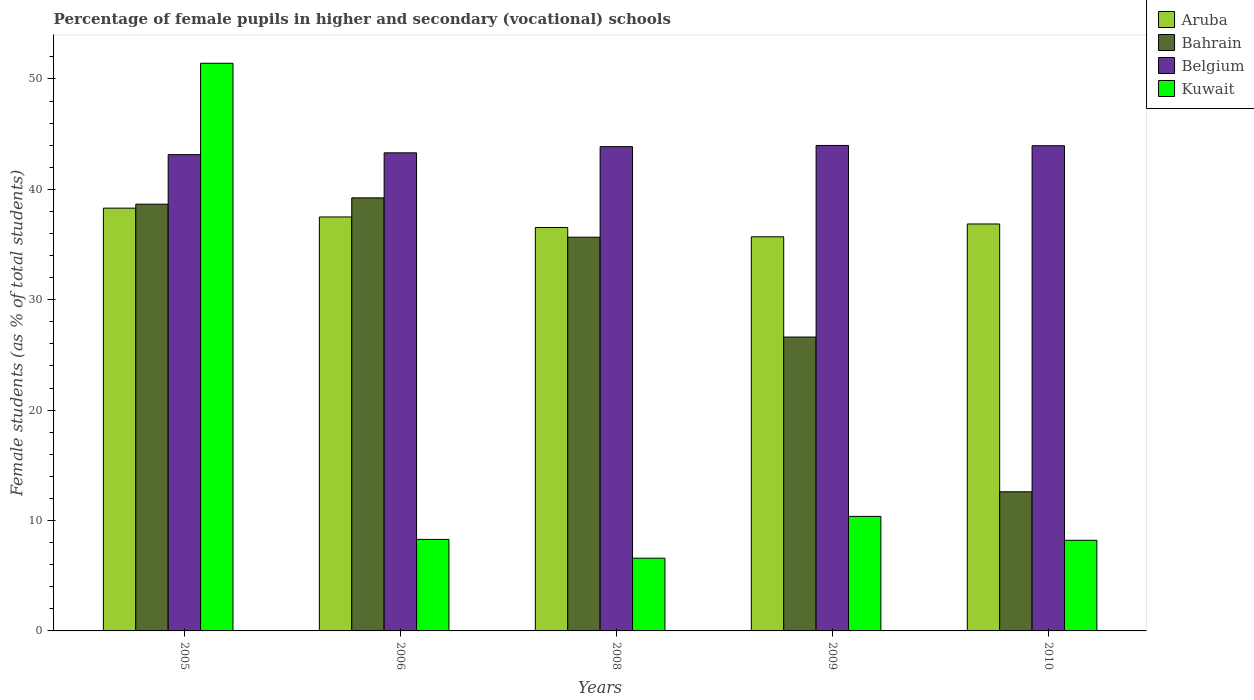How many different coloured bars are there?
Your response must be concise. 4. Are the number of bars per tick equal to the number of legend labels?
Offer a very short reply. Yes. Are the number of bars on each tick of the X-axis equal?
Your answer should be very brief. Yes. How many bars are there on the 5th tick from the left?
Provide a short and direct response. 4. How many bars are there on the 1st tick from the right?
Keep it short and to the point. 4. What is the percentage of female pupils in higher and secondary schools in Bahrain in 2010?
Ensure brevity in your answer.  12.6. Across all years, what is the maximum percentage of female pupils in higher and secondary schools in Kuwait?
Your response must be concise. 51.42. Across all years, what is the minimum percentage of female pupils in higher and secondary schools in Bahrain?
Offer a terse response. 12.6. In which year was the percentage of female pupils in higher and secondary schools in Aruba maximum?
Your answer should be very brief. 2005. In which year was the percentage of female pupils in higher and secondary schools in Aruba minimum?
Make the answer very short. 2009. What is the total percentage of female pupils in higher and secondary schools in Kuwait in the graph?
Offer a terse response. 84.89. What is the difference between the percentage of female pupils in higher and secondary schools in Kuwait in 2006 and that in 2008?
Keep it short and to the point. 1.7. What is the difference between the percentage of female pupils in higher and secondary schools in Belgium in 2010 and the percentage of female pupils in higher and secondary schools in Kuwait in 2006?
Offer a terse response. 35.66. What is the average percentage of female pupils in higher and secondary schools in Belgium per year?
Offer a terse response. 43.65. In the year 2006, what is the difference between the percentage of female pupils in higher and secondary schools in Kuwait and percentage of female pupils in higher and secondary schools in Aruba?
Provide a succinct answer. -29.21. What is the ratio of the percentage of female pupils in higher and secondary schools in Kuwait in 2008 to that in 2010?
Give a very brief answer. 0.8. Is the percentage of female pupils in higher and secondary schools in Kuwait in 2006 less than that in 2010?
Make the answer very short. No. What is the difference between the highest and the second highest percentage of female pupils in higher and secondary schools in Kuwait?
Your answer should be very brief. 41.05. What is the difference between the highest and the lowest percentage of female pupils in higher and secondary schools in Kuwait?
Your answer should be very brief. 44.83. Is the sum of the percentage of female pupils in higher and secondary schools in Belgium in 2005 and 2010 greater than the maximum percentage of female pupils in higher and secondary schools in Bahrain across all years?
Keep it short and to the point. Yes. What does the 2nd bar from the left in 2005 represents?
Provide a succinct answer. Bahrain. What does the 3rd bar from the right in 2006 represents?
Ensure brevity in your answer.  Bahrain. How many bars are there?
Give a very brief answer. 20. Are all the bars in the graph horizontal?
Your answer should be compact. No. What is the difference between two consecutive major ticks on the Y-axis?
Your answer should be compact. 10. Where does the legend appear in the graph?
Offer a very short reply. Top right. How are the legend labels stacked?
Ensure brevity in your answer.  Vertical. What is the title of the graph?
Your response must be concise. Percentage of female pupils in higher and secondary (vocational) schools. What is the label or title of the Y-axis?
Provide a short and direct response. Female students (as % of total students). What is the Female students (as % of total students) in Aruba in 2005?
Ensure brevity in your answer.  38.3. What is the Female students (as % of total students) in Bahrain in 2005?
Your answer should be very brief. 38.66. What is the Female students (as % of total students) of Belgium in 2005?
Your answer should be very brief. 43.14. What is the Female students (as % of total students) of Kuwait in 2005?
Give a very brief answer. 51.42. What is the Female students (as % of total students) of Aruba in 2006?
Make the answer very short. 37.5. What is the Female students (as % of total students) in Bahrain in 2006?
Your response must be concise. 39.23. What is the Female students (as % of total students) of Belgium in 2006?
Your response must be concise. 43.31. What is the Female students (as % of total students) of Kuwait in 2006?
Your answer should be very brief. 8.29. What is the Female students (as % of total students) in Aruba in 2008?
Make the answer very short. 36.55. What is the Female students (as % of total students) of Bahrain in 2008?
Offer a very short reply. 35.67. What is the Female students (as % of total students) of Belgium in 2008?
Offer a very short reply. 43.87. What is the Female students (as % of total students) of Kuwait in 2008?
Offer a very short reply. 6.59. What is the Female students (as % of total students) of Aruba in 2009?
Provide a short and direct response. 35.7. What is the Female students (as % of total students) in Bahrain in 2009?
Give a very brief answer. 26.62. What is the Female students (as % of total students) of Belgium in 2009?
Give a very brief answer. 43.98. What is the Female students (as % of total students) of Kuwait in 2009?
Give a very brief answer. 10.38. What is the Female students (as % of total students) of Aruba in 2010?
Your response must be concise. 36.87. What is the Female students (as % of total students) in Bahrain in 2010?
Provide a succinct answer. 12.6. What is the Female students (as % of total students) of Belgium in 2010?
Ensure brevity in your answer.  43.95. What is the Female students (as % of total students) of Kuwait in 2010?
Your answer should be compact. 8.21. Across all years, what is the maximum Female students (as % of total students) in Aruba?
Offer a very short reply. 38.3. Across all years, what is the maximum Female students (as % of total students) of Bahrain?
Give a very brief answer. 39.23. Across all years, what is the maximum Female students (as % of total students) in Belgium?
Your answer should be very brief. 43.98. Across all years, what is the maximum Female students (as % of total students) of Kuwait?
Your answer should be compact. 51.42. Across all years, what is the minimum Female students (as % of total students) in Aruba?
Ensure brevity in your answer.  35.7. Across all years, what is the minimum Female students (as % of total students) in Bahrain?
Your response must be concise. 12.6. Across all years, what is the minimum Female students (as % of total students) in Belgium?
Offer a very short reply. 43.14. Across all years, what is the minimum Female students (as % of total students) of Kuwait?
Keep it short and to the point. 6.59. What is the total Female students (as % of total students) in Aruba in the graph?
Offer a very short reply. 184.91. What is the total Female students (as % of total students) in Bahrain in the graph?
Offer a terse response. 152.78. What is the total Female students (as % of total students) in Belgium in the graph?
Make the answer very short. 218.25. What is the total Female students (as % of total students) in Kuwait in the graph?
Your response must be concise. 84.89. What is the difference between the Female students (as % of total students) of Aruba in 2005 and that in 2006?
Offer a very short reply. 0.8. What is the difference between the Female students (as % of total students) in Bahrain in 2005 and that in 2006?
Offer a terse response. -0.57. What is the difference between the Female students (as % of total students) in Belgium in 2005 and that in 2006?
Make the answer very short. -0.16. What is the difference between the Female students (as % of total students) in Kuwait in 2005 and that in 2006?
Provide a short and direct response. 43.13. What is the difference between the Female students (as % of total students) in Aruba in 2005 and that in 2008?
Make the answer very short. 1.75. What is the difference between the Female students (as % of total students) of Bahrain in 2005 and that in 2008?
Offer a terse response. 2.99. What is the difference between the Female students (as % of total students) of Belgium in 2005 and that in 2008?
Provide a succinct answer. -0.72. What is the difference between the Female students (as % of total students) in Kuwait in 2005 and that in 2008?
Your answer should be compact. 44.83. What is the difference between the Female students (as % of total students) in Aruba in 2005 and that in 2009?
Your answer should be very brief. 2.6. What is the difference between the Female students (as % of total students) of Bahrain in 2005 and that in 2009?
Your answer should be very brief. 12.04. What is the difference between the Female students (as % of total students) in Belgium in 2005 and that in 2009?
Provide a short and direct response. -0.83. What is the difference between the Female students (as % of total students) in Kuwait in 2005 and that in 2009?
Your answer should be very brief. 41.05. What is the difference between the Female students (as % of total students) in Aruba in 2005 and that in 2010?
Ensure brevity in your answer.  1.43. What is the difference between the Female students (as % of total students) of Bahrain in 2005 and that in 2010?
Keep it short and to the point. 26.05. What is the difference between the Female students (as % of total students) of Belgium in 2005 and that in 2010?
Ensure brevity in your answer.  -0.81. What is the difference between the Female students (as % of total students) in Kuwait in 2005 and that in 2010?
Keep it short and to the point. 43.21. What is the difference between the Female students (as % of total students) of Aruba in 2006 and that in 2008?
Offer a terse response. 0.95. What is the difference between the Female students (as % of total students) in Bahrain in 2006 and that in 2008?
Your answer should be compact. 3.57. What is the difference between the Female students (as % of total students) of Belgium in 2006 and that in 2008?
Ensure brevity in your answer.  -0.56. What is the difference between the Female students (as % of total students) in Kuwait in 2006 and that in 2008?
Offer a very short reply. 1.7. What is the difference between the Female students (as % of total students) in Aruba in 2006 and that in 2009?
Offer a very short reply. 1.8. What is the difference between the Female students (as % of total students) in Bahrain in 2006 and that in 2009?
Make the answer very short. 12.61. What is the difference between the Female students (as % of total students) in Belgium in 2006 and that in 2009?
Make the answer very short. -0.67. What is the difference between the Female students (as % of total students) in Kuwait in 2006 and that in 2009?
Your answer should be very brief. -2.08. What is the difference between the Female students (as % of total students) of Aruba in 2006 and that in 2010?
Offer a terse response. 0.63. What is the difference between the Female students (as % of total students) of Bahrain in 2006 and that in 2010?
Your answer should be compact. 26.63. What is the difference between the Female students (as % of total students) of Belgium in 2006 and that in 2010?
Give a very brief answer. -0.65. What is the difference between the Female students (as % of total students) of Kuwait in 2006 and that in 2010?
Ensure brevity in your answer.  0.08. What is the difference between the Female students (as % of total students) of Aruba in 2008 and that in 2009?
Your answer should be compact. 0.84. What is the difference between the Female students (as % of total students) in Bahrain in 2008 and that in 2009?
Offer a terse response. 9.04. What is the difference between the Female students (as % of total students) of Belgium in 2008 and that in 2009?
Your answer should be compact. -0.11. What is the difference between the Female students (as % of total students) of Kuwait in 2008 and that in 2009?
Make the answer very short. -3.79. What is the difference between the Female students (as % of total students) in Aruba in 2008 and that in 2010?
Offer a terse response. -0.32. What is the difference between the Female students (as % of total students) in Bahrain in 2008 and that in 2010?
Offer a very short reply. 23.06. What is the difference between the Female students (as % of total students) in Belgium in 2008 and that in 2010?
Ensure brevity in your answer.  -0.09. What is the difference between the Female students (as % of total students) of Kuwait in 2008 and that in 2010?
Make the answer very short. -1.62. What is the difference between the Female students (as % of total students) of Aruba in 2009 and that in 2010?
Provide a succinct answer. -1.16. What is the difference between the Female students (as % of total students) of Bahrain in 2009 and that in 2010?
Give a very brief answer. 14.02. What is the difference between the Female students (as % of total students) in Belgium in 2009 and that in 2010?
Your answer should be compact. 0.02. What is the difference between the Female students (as % of total students) of Kuwait in 2009 and that in 2010?
Make the answer very short. 2.16. What is the difference between the Female students (as % of total students) of Aruba in 2005 and the Female students (as % of total students) of Bahrain in 2006?
Offer a very short reply. -0.93. What is the difference between the Female students (as % of total students) of Aruba in 2005 and the Female students (as % of total students) of Belgium in 2006?
Offer a very short reply. -5.01. What is the difference between the Female students (as % of total students) in Aruba in 2005 and the Female students (as % of total students) in Kuwait in 2006?
Your response must be concise. 30.01. What is the difference between the Female students (as % of total students) in Bahrain in 2005 and the Female students (as % of total students) in Belgium in 2006?
Provide a short and direct response. -4.65. What is the difference between the Female students (as % of total students) of Bahrain in 2005 and the Female students (as % of total students) of Kuwait in 2006?
Offer a very short reply. 30.37. What is the difference between the Female students (as % of total students) in Belgium in 2005 and the Female students (as % of total students) in Kuwait in 2006?
Make the answer very short. 34.85. What is the difference between the Female students (as % of total students) in Aruba in 2005 and the Female students (as % of total students) in Bahrain in 2008?
Your answer should be very brief. 2.63. What is the difference between the Female students (as % of total students) of Aruba in 2005 and the Female students (as % of total students) of Belgium in 2008?
Your response must be concise. -5.57. What is the difference between the Female students (as % of total students) in Aruba in 2005 and the Female students (as % of total students) in Kuwait in 2008?
Your response must be concise. 31.71. What is the difference between the Female students (as % of total students) of Bahrain in 2005 and the Female students (as % of total students) of Belgium in 2008?
Give a very brief answer. -5.21. What is the difference between the Female students (as % of total students) of Bahrain in 2005 and the Female students (as % of total students) of Kuwait in 2008?
Make the answer very short. 32.07. What is the difference between the Female students (as % of total students) of Belgium in 2005 and the Female students (as % of total students) of Kuwait in 2008?
Make the answer very short. 36.56. What is the difference between the Female students (as % of total students) of Aruba in 2005 and the Female students (as % of total students) of Bahrain in 2009?
Ensure brevity in your answer.  11.68. What is the difference between the Female students (as % of total students) in Aruba in 2005 and the Female students (as % of total students) in Belgium in 2009?
Give a very brief answer. -5.68. What is the difference between the Female students (as % of total students) of Aruba in 2005 and the Female students (as % of total students) of Kuwait in 2009?
Offer a very short reply. 27.92. What is the difference between the Female students (as % of total students) of Bahrain in 2005 and the Female students (as % of total students) of Belgium in 2009?
Ensure brevity in your answer.  -5.32. What is the difference between the Female students (as % of total students) in Bahrain in 2005 and the Female students (as % of total students) in Kuwait in 2009?
Your answer should be compact. 28.28. What is the difference between the Female students (as % of total students) in Belgium in 2005 and the Female students (as % of total students) in Kuwait in 2009?
Give a very brief answer. 32.77. What is the difference between the Female students (as % of total students) of Aruba in 2005 and the Female students (as % of total students) of Bahrain in 2010?
Keep it short and to the point. 25.69. What is the difference between the Female students (as % of total students) in Aruba in 2005 and the Female students (as % of total students) in Belgium in 2010?
Provide a succinct answer. -5.66. What is the difference between the Female students (as % of total students) of Aruba in 2005 and the Female students (as % of total students) of Kuwait in 2010?
Offer a terse response. 30.09. What is the difference between the Female students (as % of total students) of Bahrain in 2005 and the Female students (as % of total students) of Belgium in 2010?
Offer a terse response. -5.3. What is the difference between the Female students (as % of total students) in Bahrain in 2005 and the Female students (as % of total students) in Kuwait in 2010?
Give a very brief answer. 30.45. What is the difference between the Female students (as % of total students) in Belgium in 2005 and the Female students (as % of total students) in Kuwait in 2010?
Provide a succinct answer. 34.93. What is the difference between the Female students (as % of total students) of Aruba in 2006 and the Female students (as % of total students) of Bahrain in 2008?
Your answer should be very brief. 1.83. What is the difference between the Female students (as % of total students) in Aruba in 2006 and the Female students (as % of total students) in Belgium in 2008?
Give a very brief answer. -6.37. What is the difference between the Female students (as % of total students) of Aruba in 2006 and the Female students (as % of total students) of Kuwait in 2008?
Provide a succinct answer. 30.91. What is the difference between the Female students (as % of total students) of Bahrain in 2006 and the Female students (as % of total students) of Belgium in 2008?
Ensure brevity in your answer.  -4.64. What is the difference between the Female students (as % of total students) in Bahrain in 2006 and the Female students (as % of total students) in Kuwait in 2008?
Offer a terse response. 32.64. What is the difference between the Female students (as % of total students) in Belgium in 2006 and the Female students (as % of total students) in Kuwait in 2008?
Provide a succinct answer. 36.72. What is the difference between the Female students (as % of total students) of Aruba in 2006 and the Female students (as % of total students) of Bahrain in 2009?
Offer a very short reply. 10.88. What is the difference between the Female students (as % of total students) in Aruba in 2006 and the Female students (as % of total students) in Belgium in 2009?
Provide a short and direct response. -6.48. What is the difference between the Female students (as % of total students) of Aruba in 2006 and the Female students (as % of total students) of Kuwait in 2009?
Provide a short and direct response. 27.12. What is the difference between the Female students (as % of total students) of Bahrain in 2006 and the Female students (as % of total students) of Belgium in 2009?
Your answer should be very brief. -4.75. What is the difference between the Female students (as % of total students) of Bahrain in 2006 and the Female students (as % of total students) of Kuwait in 2009?
Provide a succinct answer. 28.85. What is the difference between the Female students (as % of total students) of Belgium in 2006 and the Female students (as % of total students) of Kuwait in 2009?
Your answer should be very brief. 32.93. What is the difference between the Female students (as % of total students) of Aruba in 2006 and the Female students (as % of total students) of Bahrain in 2010?
Ensure brevity in your answer.  24.9. What is the difference between the Female students (as % of total students) of Aruba in 2006 and the Female students (as % of total students) of Belgium in 2010?
Ensure brevity in your answer.  -6.45. What is the difference between the Female students (as % of total students) of Aruba in 2006 and the Female students (as % of total students) of Kuwait in 2010?
Keep it short and to the point. 29.29. What is the difference between the Female students (as % of total students) in Bahrain in 2006 and the Female students (as % of total students) in Belgium in 2010?
Provide a short and direct response. -4.72. What is the difference between the Female students (as % of total students) in Bahrain in 2006 and the Female students (as % of total students) in Kuwait in 2010?
Your answer should be very brief. 31.02. What is the difference between the Female students (as % of total students) in Belgium in 2006 and the Female students (as % of total students) in Kuwait in 2010?
Give a very brief answer. 35.1. What is the difference between the Female students (as % of total students) in Aruba in 2008 and the Female students (as % of total students) in Bahrain in 2009?
Your answer should be compact. 9.92. What is the difference between the Female students (as % of total students) in Aruba in 2008 and the Female students (as % of total students) in Belgium in 2009?
Provide a succinct answer. -7.43. What is the difference between the Female students (as % of total students) in Aruba in 2008 and the Female students (as % of total students) in Kuwait in 2009?
Provide a succinct answer. 26.17. What is the difference between the Female students (as % of total students) in Bahrain in 2008 and the Female students (as % of total students) in Belgium in 2009?
Make the answer very short. -8.31. What is the difference between the Female students (as % of total students) of Bahrain in 2008 and the Female students (as % of total students) of Kuwait in 2009?
Offer a very short reply. 25.29. What is the difference between the Female students (as % of total students) of Belgium in 2008 and the Female students (as % of total students) of Kuwait in 2009?
Your answer should be compact. 33.49. What is the difference between the Female students (as % of total students) of Aruba in 2008 and the Female students (as % of total students) of Bahrain in 2010?
Make the answer very short. 23.94. What is the difference between the Female students (as % of total students) of Aruba in 2008 and the Female students (as % of total students) of Belgium in 2010?
Give a very brief answer. -7.41. What is the difference between the Female students (as % of total students) of Aruba in 2008 and the Female students (as % of total students) of Kuwait in 2010?
Ensure brevity in your answer.  28.33. What is the difference between the Female students (as % of total students) in Bahrain in 2008 and the Female students (as % of total students) in Belgium in 2010?
Your response must be concise. -8.29. What is the difference between the Female students (as % of total students) of Bahrain in 2008 and the Female students (as % of total students) of Kuwait in 2010?
Your response must be concise. 27.45. What is the difference between the Female students (as % of total students) of Belgium in 2008 and the Female students (as % of total students) of Kuwait in 2010?
Offer a terse response. 35.66. What is the difference between the Female students (as % of total students) of Aruba in 2009 and the Female students (as % of total students) of Bahrain in 2010?
Your answer should be compact. 23.1. What is the difference between the Female students (as % of total students) in Aruba in 2009 and the Female students (as % of total students) in Belgium in 2010?
Your response must be concise. -8.25. What is the difference between the Female students (as % of total students) of Aruba in 2009 and the Female students (as % of total students) of Kuwait in 2010?
Your answer should be very brief. 27.49. What is the difference between the Female students (as % of total students) of Bahrain in 2009 and the Female students (as % of total students) of Belgium in 2010?
Your answer should be very brief. -17.33. What is the difference between the Female students (as % of total students) of Bahrain in 2009 and the Female students (as % of total students) of Kuwait in 2010?
Ensure brevity in your answer.  18.41. What is the difference between the Female students (as % of total students) of Belgium in 2009 and the Female students (as % of total students) of Kuwait in 2010?
Your answer should be compact. 35.77. What is the average Female students (as % of total students) in Aruba per year?
Make the answer very short. 36.98. What is the average Female students (as % of total students) in Bahrain per year?
Give a very brief answer. 30.56. What is the average Female students (as % of total students) in Belgium per year?
Offer a terse response. 43.65. What is the average Female students (as % of total students) in Kuwait per year?
Your answer should be compact. 16.98. In the year 2005, what is the difference between the Female students (as % of total students) of Aruba and Female students (as % of total students) of Bahrain?
Your answer should be compact. -0.36. In the year 2005, what is the difference between the Female students (as % of total students) in Aruba and Female students (as % of total students) in Belgium?
Make the answer very short. -4.85. In the year 2005, what is the difference between the Female students (as % of total students) of Aruba and Female students (as % of total students) of Kuwait?
Provide a succinct answer. -13.13. In the year 2005, what is the difference between the Female students (as % of total students) in Bahrain and Female students (as % of total students) in Belgium?
Provide a succinct answer. -4.49. In the year 2005, what is the difference between the Female students (as % of total students) of Bahrain and Female students (as % of total students) of Kuwait?
Provide a short and direct response. -12.77. In the year 2005, what is the difference between the Female students (as % of total students) in Belgium and Female students (as % of total students) in Kuwait?
Your answer should be very brief. -8.28. In the year 2006, what is the difference between the Female students (as % of total students) in Aruba and Female students (as % of total students) in Bahrain?
Your answer should be compact. -1.73. In the year 2006, what is the difference between the Female students (as % of total students) of Aruba and Female students (as % of total students) of Belgium?
Provide a succinct answer. -5.81. In the year 2006, what is the difference between the Female students (as % of total students) of Aruba and Female students (as % of total students) of Kuwait?
Ensure brevity in your answer.  29.21. In the year 2006, what is the difference between the Female students (as % of total students) of Bahrain and Female students (as % of total students) of Belgium?
Offer a terse response. -4.08. In the year 2006, what is the difference between the Female students (as % of total students) of Bahrain and Female students (as % of total students) of Kuwait?
Offer a terse response. 30.94. In the year 2006, what is the difference between the Female students (as % of total students) of Belgium and Female students (as % of total students) of Kuwait?
Offer a terse response. 35.02. In the year 2008, what is the difference between the Female students (as % of total students) in Aruba and Female students (as % of total students) in Bahrain?
Your answer should be compact. 0.88. In the year 2008, what is the difference between the Female students (as % of total students) in Aruba and Female students (as % of total students) in Belgium?
Offer a very short reply. -7.32. In the year 2008, what is the difference between the Female students (as % of total students) of Aruba and Female students (as % of total students) of Kuwait?
Ensure brevity in your answer.  29.96. In the year 2008, what is the difference between the Female students (as % of total students) in Bahrain and Female students (as % of total students) in Belgium?
Provide a succinct answer. -8.2. In the year 2008, what is the difference between the Female students (as % of total students) of Bahrain and Female students (as % of total students) of Kuwait?
Make the answer very short. 29.08. In the year 2008, what is the difference between the Female students (as % of total students) in Belgium and Female students (as % of total students) in Kuwait?
Your response must be concise. 37.28. In the year 2009, what is the difference between the Female students (as % of total students) in Aruba and Female students (as % of total students) in Bahrain?
Your response must be concise. 9.08. In the year 2009, what is the difference between the Female students (as % of total students) in Aruba and Female students (as % of total students) in Belgium?
Offer a very short reply. -8.27. In the year 2009, what is the difference between the Female students (as % of total students) of Aruba and Female students (as % of total students) of Kuwait?
Your answer should be very brief. 25.33. In the year 2009, what is the difference between the Female students (as % of total students) in Bahrain and Female students (as % of total students) in Belgium?
Give a very brief answer. -17.36. In the year 2009, what is the difference between the Female students (as % of total students) in Bahrain and Female students (as % of total students) in Kuwait?
Offer a very short reply. 16.25. In the year 2009, what is the difference between the Female students (as % of total students) of Belgium and Female students (as % of total students) of Kuwait?
Your response must be concise. 33.6. In the year 2010, what is the difference between the Female students (as % of total students) of Aruba and Female students (as % of total students) of Bahrain?
Keep it short and to the point. 24.26. In the year 2010, what is the difference between the Female students (as % of total students) of Aruba and Female students (as % of total students) of Belgium?
Provide a succinct answer. -7.09. In the year 2010, what is the difference between the Female students (as % of total students) of Aruba and Female students (as % of total students) of Kuwait?
Provide a succinct answer. 28.65. In the year 2010, what is the difference between the Female students (as % of total students) of Bahrain and Female students (as % of total students) of Belgium?
Provide a short and direct response. -31.35. In the year 2010, what is the difference between the Female students (as % of total students) in Bahrain and Female students (as % of total students) in Kuwait?
Your answer should be very brief. 4.39. In the year 2010, what is the difference between the Female students (as % of total students) of Belgium and Female students (as % of total students) of Kuwait?
Your response must be concise. 35.74. What is the ratio of the Female students (as % of total students) of Aruba in 2005 to that in 2006?
Give a very brief answer. 1.02. What is the ratio of the Female students (as % of total students) in Bahrain in 2005 to that in 2006?
Your answer should be very brief. 0.99. What is the ratio of the Female students (as % of total students) in Kuwait in 2005 to that in 2006?
Keep it short and to the point. 6.2. What is the ratio of the Female students (as % of total students) in Aruba in 2005 to that in 2008?
Provide a short and direct response. 1.05. What is the ratio of the Female students (as % of total students) of Bahrain in 2005 to that in 2008?
Your answer should be very brief. 1.08. What is the ratio of the Female students (as % of total students) in Belgium in 2005 to that in 2008?
Keep it short and to the point. 0.98. What is the ratio of the Female students (as % of total students) in Kuwait in 2005 to that in 2008?
Make the answer very short. 7.8. What is the ratio of the Female students (as % of total students) in Aruba in 2005 to that in 2009?
Provide a short and direct response. 1.07. What is the ratio of the Female students (as % of total students) in Bahrain in 2005 to that in 2009?
Ensure brevity in your answer.  1.45. What is the ratio of the Female students (as % of total students) of Belgium in 2005 to that in 2009?
Make the answer very short. 0.98. What is the ratio of the Female students (as % of total students) of Kuwait in 2005 to that in 2009?
Your answer should be compact. 4.96. What is the ratio of the Female students (as % of total students) of Aruba in 2005 to that in 2010?
Give a very brief answer. 1.04. What is the ratio of the Female students (as % of total students) in Bahrain in 2005 to that in 2010?
Provide a succinct answer. 3.07. What is the ratio of the Female students (as % of total students) of Belgium in 2005 to that in 2010?
Keep it short and to the point. 0.98. What is the ratio of the Female students (as % of total students) of Kuwait in 2005 to that in 2010?
Ensure brevity in your answer.  6.26. What is the ratio of the Female students (as % of total students) in Aruba in 2006 to that in 2008?
Offer a very short reply. 1.03. What is the ratio of the Female students (as % of total students) in Belgium in 2006 to that in 2008?
Provide a succinct answer. 0.99. What is the ratio of the Female students (as % of total students) of Kuwait in 2006 to that in 2008?
Ensure brevity in your answer.  1.26. What is the ratio of the Female students (as % of total students) of Aruba in 2006 to that in 2009?
Your answer should be very brief. 1.05. What is the ratio of the Female students (as % of total students) in Bahrain in 2006 to that in 2009?
Make the answer very short. 1.47. What is the ratio of the Female students (as % of total students) in Kuwait in 2006 to that in 2009?
Keep it short and to the point. 0.8. What is the ratio of the Female students (as % of total students) of Aruba in 2006 to that in 2010?
Provide a short and direct response. 1.02. What is the ratio of the Female students (as % of total students) of Bahrain in 2006 to that in 2010?
Keep it short and to the point. 3.11. What is the ratio of the Female students (as % of total students) in Kuwait in 2006 to that in 2010?
Ensure brevity in your answer.  1.01. What is the ratio of the Female students (as % of total students) of Aruba in 2008 to that in 2009?
Make the answer very short. 1.02. What is the ratio of the Female students (as % of total students) of Bahrain in 2008 to that in 2009?
Provide a succinct answer. 1.34. What is the ratio of the Female students (as % of total students) in Belgium in 2008 to that in 2009?
Provide a succinct answer. 1. What is the ratio of the Female students (as % of total students) in Kuwait in 2008 to that in 2009?
Make the answer very short. 0.64. What is the ratio of the Female students (as % of total students) in Aruba in 2008 to that in 2010?
Your answer should be compact. 0.99. What is the ratio of the Female students (as % of total students) in Bahrain in 2008 to that in 2010?
Provide a succinct answer. 2.83. What is the ratio of the Female students (as % of total students) of Belgium in 2008 to that in 2010?
Ensure brevity in your answer.  1. What is the ratio of the Female students (as % of total students) in Kuwait in 2008 to that in 2010?
Ensure brevity in your answer.  0.8. What is the ratio of the Female students (as % of total students) in Aruba in 2009 to that in 2010?
Your answer should be very brief. 0.97. What is the ratio of the Female students (as % of total students) in Bahrain in 2009 to that in 2010?
Your answer should be compact. 2.11. What is the ratio of the Female students (as % of total students) of Kuwait in 2009 to that in 2010?
Your answer should be compact. 1.26. What is the difference between the highest and the second highest Female students (as % of total students) in Aruba?
Offer a very short reply. 0.8. What is the difference between the highest and the second highest Female students (as % of total students) of Bahrain?
Make the answer very short. 0.57. What is the difference between the highest and the second highest Female students (as % of total students) in Belgium?
Keep it short and to the point. 0.02. What is the difference between the highest and the second highest Female students (as % of total students) of Kuwait?
Make the answer very short. 41.05. What is the difference between the highest and the lowest Female students (as % of total students) of Aruba?
Make the answer very short. 2.6. What is the difference between the highest and the lowest Female students (as % of total students) in Bahrain?
Your answer should be very brief. 26.63. What is the difference between the highest and the lowest Female students (as % of total students) in Belgium?
Give a very brief answer. 0.83. What is the difference between the highest and the lowest Female students (as % of total students) in Kuwait?
Provide a succinct answer. 44.83. 